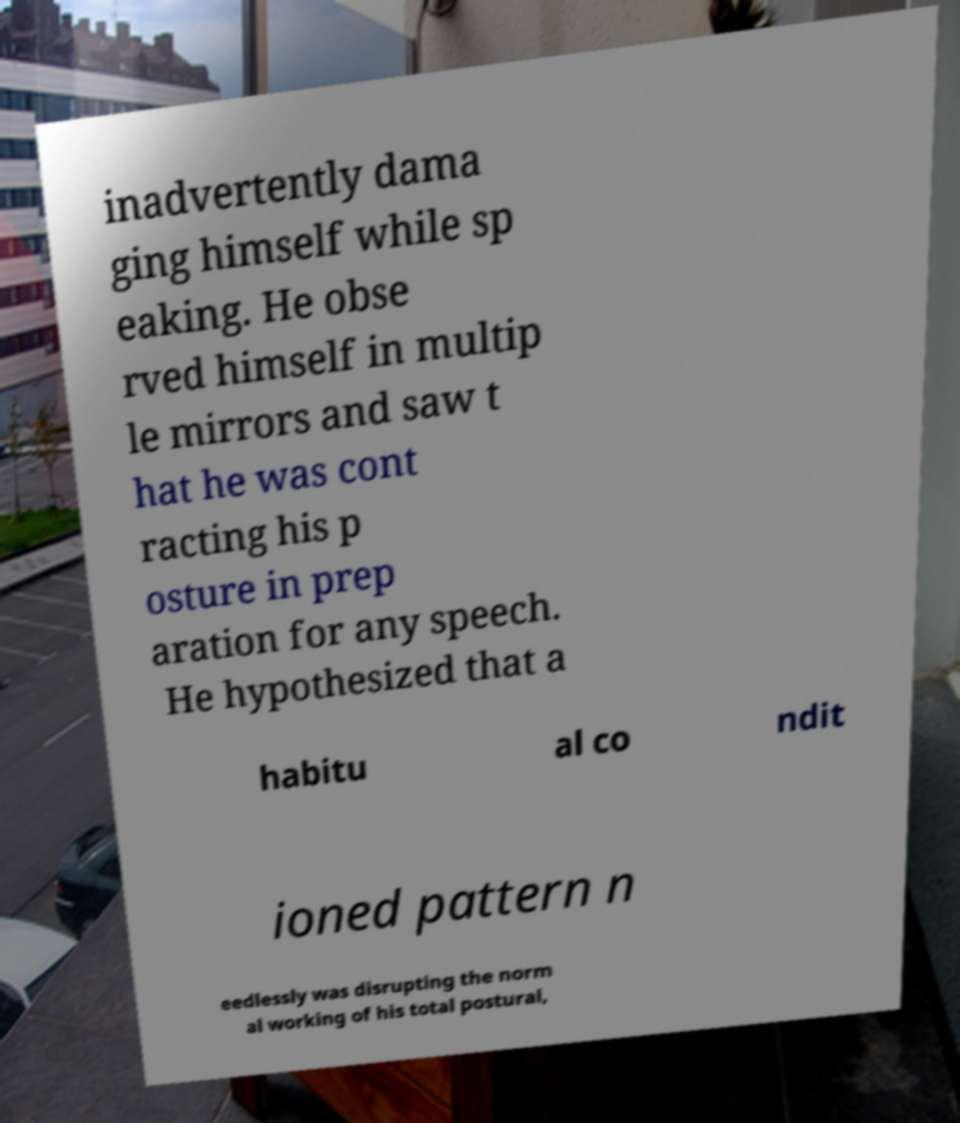Please identify and transcribe the text found in this image. inadvertently dama ging himself while sp eaking. He obse rved himself in multip le mirrors and saw t hat he was cont racting his p osture in prep aration for any speech. He hypothesized that a habitu al co ndit ioned pattern n eedlessly was disrupting the norm al working of his total postural, 